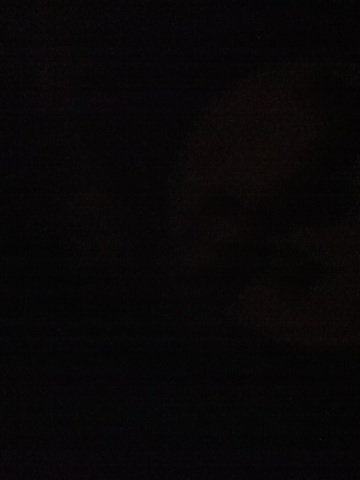Can you imagine what might be present in this image if it were clearer? Imagining based on the dark nature of the image, it could be a cityscape at night, where buildings and street lights are present but not clearly visible. It could also be an indoor setting with the lights turned off. 